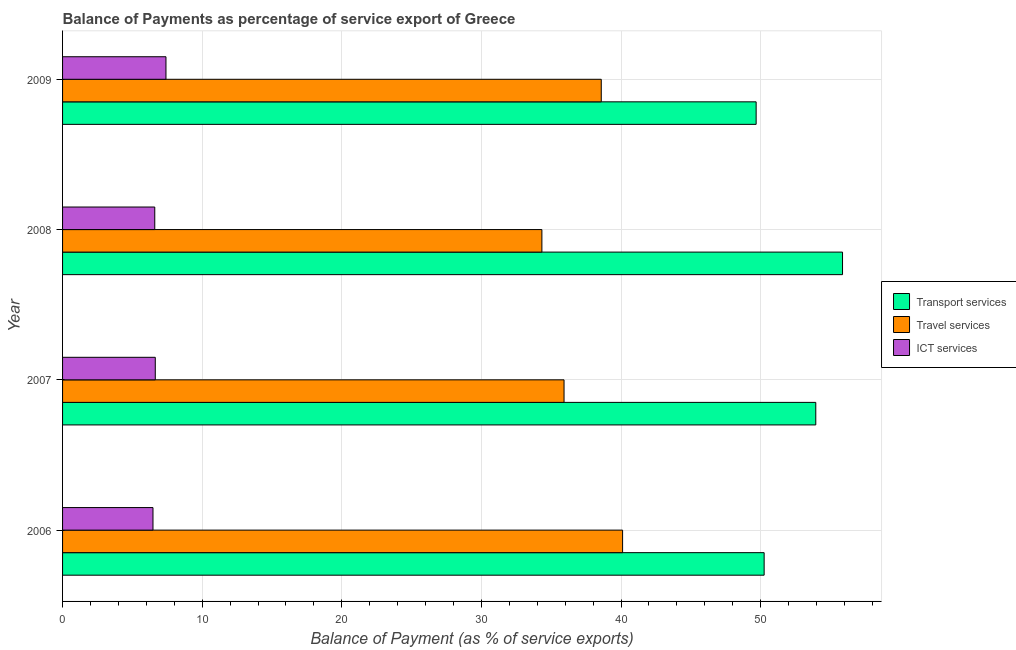How many different coloured bars are there?
Give a very brief answer. 3. How many groups of bars are there?
Your answer should be compact. 4. Are the number of bars on each tick of the Y-axis equal?
Provide a short and direct response. Yes. How many bars are there on the 3rd tick from the top?
Keep it short and to the point. 3. How many bars are there on the 4th tick from the bottom?
Keep it short and to the point. 3. In how many cases, is the number of bars for a given year not equal to the number of legend labels?
Keep it short and to the point. 0. What is the balance of payment of ict services in 2007?
Make the answer very short. 6.64. Across all years, what is the maximum balance of payment of ict services?
Keep it short and to the point. 7.41. Across all years, what is the minimum balance of payment of transport services?
Give a very brief answer. 49.68. In which year was the balance of payment of ict services minimum?
Give a very brief answer. 2006. What is the total balance of payment of travel services in the graph?
Keep it short and to the point. 148.96. What is the difference between the balance of payment of transport services in 2008 and that in 2009?
Provide a short and direct response. 6.19. What is the difference between the balance of payment of ict services in 2006 and the balance of payment of transport services in 2009?
Ensure brevity in your answer.  -43.2. What is the average balance of payment of transport services per year?
Provide a succinct answer. 52.44. In the year 2006, what is the difference between the balance of payment of transport services and balance of payment of travel services?
Your response must be concise. 10.14. What is the ratio of the balance of payment of travel services in 2008 to that in 2009?
Your response must be concise. 0.89. Is the balance of payment of travel services in 2007 less than that in 2009?
Your answer should be compact. Yes. What is the difference between the highest and the second highest balance of payment of transport services?
Provide a succinct answer. 1.92. What is the difference between the highest and the lowest balance of payment of transport services?
Offer a terse response. 6.19. In how many years, is the balance of payment of travel services greater than the average balance of payment of travel services taken over all years?
Your answer should be compact. 2. What does the 1st bar from the top in 2006 represents?
Provide a short and direct response. ICT services. What does the 1st bar from the bottom in 2008 represents?
Ensure brevity in your answer.  Transport services. What is the difference between two consecutive major ticks on the X-axis?
Make the answer very short. 10. Does the graph contain grids?
Provide a short and direct response. Yes. How many legend labels are there?
Provide a succinct answer. 3. What is the title of the graph?
Ensure brevity in your answer.  Balance of Payments as percentage of service export of Greece. What is the label or title of the X-axis?
Provide a short and direct response. Balance of Payment (as % of service exports). What is the label or title of the Y-axis?
Provide a succinct answer. Year. What is the Balance of Payment (as % of service exports) in Transport services in 2006?
Make the answer very short. 50.25. What is the Balance of Payment (as % of service exports) in Travel services in 2006?
Your response must be concise. 40.11. What is the Balance of Payment (as % of service exports) of ICT services in 2006?
Offer a terse response. 6.48. What is the Balance of Payment (as % of service exports) in Transport services in 2007?
Your answer should be compact. 53.95. What is the Balance of Payment (as % of service exports) of Travel services in 2007?
Your answer should be compact. 35.92. What is the Balance of Payment (as % of service exports) of ICT services in 2007?
Make the answer very short. 6.64. What is the Balance of Payment (as % of service exports) in Transport services in 2008?
Offer a terse response. 55.87. What is the Balance of Payment (as % of service exports) of Travel services in 2008?
Provide a succinct answer. 34.33. What is the Balance of Payment (as % of service exports) in ICT services in 2008?
Keep it short and to the point. 6.6. What is the Balance of Payment (as % of service exports) in Transport services in 2009?
Offer a very short reply. 49.68. What is the Balance of Payment (as % of service exports) in Travel services in 2009?
Your response must be concise. 38.59. What is the Balance of Payment (as % of service exports) of ICT services in 2009?
Give a very brief answer. 7.41. Across all years, what is the maximum Balance of Payment (as % of service exports) of Transport services?
Offer a very short reply. 55.87. Across all years, what is the maximum Balance of Payment (as % of service exports) of Travel services?
Offer a very short reply. 40.11. Across all years, what is the maximum Balance of Payment (as % of service exports) of ICT services?
Your response must be concise. 7.41. Across all years, what is the minimum Balance of Payment (as % of service exports) in Transport services?
Your response must be concise. 49.68. Across all years, what is the minimum Balance of Payment (as % of service exports) in Travel services?
Ensure brevity in your answer.  34.33. Across all years, what is the minimum Balance of Payment (as % of service exports) of ICT services?
Provide a succinct answer. 6.48. What is the total Balance of Payment (as % of service exports) in Transport services in the graph?
Ensure brevity in your answer.  209.75. What is the total Balance of Payment (as % of service exports) in Travel services in the graph?
Give a very brief answer. 148.96. What is the total Balance of Payment (as % of service exports) of ICT services in the graph?
Offer a very short reply. 27.13. What is the difference between the Balance of Payment (as % of service exports) of Transport services in 2006 and that in 2007?
Your answer should be very brief. -3.7. What is the difference between the Balance of Payment (as % of service exports) of Travel services in 2006 and that in 2007?
Your response must be concise. 4.19. What is the difference between the Balance of Payment (as % of service exports) in ICT services in 2006 and that in 2007?
Your response must be concise. -0.16. What is the difference between the Balance of Payment (as % of service exports) of Transport services in 2006 and that in 2008?
Your answer should be compact. -5.61. What is the difference between the Balance of Payment (as % of service exports) of Travel services in 2006 and that in 2008?
Make the answer very short. 5.78. What is the difference between the Balance of Payment (as % of service exports) of ICT services in 2006 and that in 2008?
Make the answer very short. -0.13. What is the difference between the Balance of Payment (as % of service exports) in Transport services in 2006 and that in 2009?
Offer a terse response. 0.57. What is the difference between the Balance of Payment (as % of service exports) of Travel services in 2006 and that in 2009?
Offer a very short reply. 1.53. What is the difference between the Balance of Payment (as % of service exports) of ICT services in 2006 and that in 2009?
Your answer should be compact. -0.93. What is the difference between the Balance of Payment (as % of service exports) in Transport services in 2007 and that in 2008?
Offer a terse response. -1.92. What is the difference between the Balance of Payment (as % of service exports) of Travel services in 2007 and that in 2008?
Your answer should be compact. 1.59. What is the difference between the Balance of Payment (as % of service exports) in ICT services in 2007 and that in 2008?
Ensure brevity in your answer.  0.04. What is the difference between the Balance of Payment (as % of service exports) of Transport services in 2007 and that in 2009?
Provide a succinct answer. 4.27. What is the difference between the Balance of Payment (as % of service exports) in Travel services in 2007 and that in 2009?
Offer a very short reply. -2.67. What is the difference between the Balance of Payment (as % of service exports) in ICT services in 2007 and that in 2009?
Ensure brevity in your answer.  -0.77. What is the difference between the Balance of Payment (as % of service exports) of Transport services in 2008 and that in 2009?
Give a very brief answer. 6.19. What is the difference between the Balance of Payment (as % of service exports) of Travel services in 2008 and that in 2009?
Keep it short and to the point. -4.25. What is the difference between the Balance of Payment (as % of service exports) in ICT services in 2008 and that in 2009?
Make the answer very short. -0.8. What is the difference between the Balance of Payment (as % of service exports) of Transport services in 2006 and the Balance of Payment (as % of service exports) of Travel services in 2007?
Offer a very short reply. 14.33. What is the difference between the Balance of Payment (as % of service exports) of Transport services in 2006 and the Balance of Payment (as % of service exports) of ICT services in 2007?
Provide a succinct answer. 43.61. What is the difference between the Balance of Payment (as % of service exports) in Travel services in 2006 and the Balance of Payment (as % of service exports) in ICT services in 2007?
Your answer should be very brief. 33.47. What is the difference between the Balance of Payment (as % of service exports) of Transport services in 2006 and the Balance of Payment (as % of service exports) of Travel services in 2008?
Offer a terse response. 15.92. What is the difference between the Balance of Payment (as % of service exports) of Transport services in 2006 and the Balance of Payment (as % of service exports) of ICT services in 2008?
Your answer should be very brief. 43.65. What is the difference between the Balance of Payment (as % of service exports) in Travel services in 2006 and the Balance of Payment (as % of service exports) in ICT services in 2008?
Your response must be concise. 33.51. What is the difference between the Balance of Payment (as % of service exports) in Transport services in 2006 and the Balance of Payment (as % of service exports) in Travel services in 2009?
Make the answer very short. 11.67. What is the difference between the Balance of Payment (as % of service exports) of Transport services in 2006 and the Balance of Payment (as % of service exports) of ICT services in 2009?
Your answer should be compact. 42.85. What is the difference between the Balance of Payment (as % of service exports) of Travel services in 2006 and the Balance of Payment (as % of service exports) of ICT services in 2009?
Offer a very short reply. 32.71. What is the difference between the Balance of Payment (as % of service exports) in Transport services in 2007 and the Balance of Payment (as % of service exports) in Travel services in 2008?
Offer a terse response. 19.62. What is the difference between the Balance of Payment (as % of service exports) in Transport services in 2007 and the Balance of Payment (as % of service exports) in ICT services in 2008?
Your answer should be compact. 47.35. What is the difference between the Balance of Payment (as % of service exports) in Travel services in 2007 and the Balance of Payment (as % of service exports) in ICT services in 2008?
Offer a very short reply. 29.32. What is the difference between the Balance of Payment (as % of service exports) in Transport services in 2007 and the Balance of Payment (as % of service exports) in Travel services in 2009?
Your answer should be very brief. 15.37. What is the difference between the Balance of Payment (as % of service exports) of Transport services in 2007 and the Balance of Payment (as % of service exports) of ICT services in 2009?
Your response must be concise. 46.55. What is the difference between the Balance of Payment (as % of service exports) in Travel services in 2007 and the Balance of Payment (as % of service exports) in ICT services in 2009?
Offer a terse response. 28.51. What is the difference between the Balance of Payment (as % of service exports) of Transport services in 2008 and the Balance of Payment (as % of service exports) of Travel services in 2009?
Your answer should be compact. 17.28. What is the difference between the Balance of Payment (as % of service exports) in Transport services in 2008 and the Balance of Payment (as % of service exports) in ICT services in 2009?
Your answer should be very brief. 48.46. What is the difference between the Balance of Payment (as % of service exports) of Travel services in 2008 and the Balance of Payment (as % of service exports) of ICT services in 2009?
Offer a very short reply. 26.93. What is the average Balance of Payment (as % of service exports) in Transport services per year?
Make the answer very short. 52.44. What is the average Balance of Payment (as % of service exports) in Travel services per year?
Keep it short and to the point. 37.24. What is the average Balance of Payment (as % of service exports) of ICT services per year?
Offer a terse response. 6.78. In the year 2006, what is the difference between the Balance of Payment (as % of service exports) of Transport services and Balance of Payment (as % of service exports) of Travel services?
Make the answer very short. 10.14. In the year 2006, what is the difference between the Balance of Payment (as % of service exports) of Transport services and Balance of Payment (as % of service exports) of ICT services?
Give a very brief answer. 43.78. In the year 2006, what is the difference between the Balance of Payment (as % of service exports) of Travel services and Balance of Payment (as % of service exports) of ICT services?
Your response must be concise. 33.64. In the year 2007, what is the difference between the Balance of Payment (as % of service exports) in Transport services and Balance of Payment (as % of service exports) in Travel services?
Ensure brevity in your answer.  18.03. In the year 2007, what is the difference between the Balance of Payment (as % of service exports) of Transport services and Balance of Payment (as % of service exports) of ICT services?
Your answer should be compact. 47.31. In the year 2007, what is the difference between the Balance of Payment (as % of service exports) in Travel services and Balance of Payment (as % of service exports) in ICT services?
Give a very brief answer. 29.28. In the year 2008, what is the difference between the Balance of Payment (as % of service exports) in Transport services and Balance of Payment (as % of service exports) in Travel services?
Keep it short and to the point. 21.53. In the year 2008, what is the difference between the Balance of Payment (as % of service exports) in Transport services and Balance of Payment (as % of service exports) in ICT services?
Offer a terse response. 49.26. In the year 2008, what is the difference between the Balance of Payment (as % of service exports) in Travel services and Balance of Payment (as % of service exports) in ICT services?
Offer a very short reply. 27.73. In the year 2009, what is the difference between the Balance of Payment (as % of service exports) of Transport services and Balance of Payment (as % of service exports) of Travel services?
Give a very brief answer. 11.09. In the year 2009, what is the difference between the Balance of Payment (as % of service exports) in Transport services and Balance of Payment (as % of service exports) in ICT services?
Your answer should be very brief. 42.27. In the year 2009, what is the difference between the Balance of Payment (as % of service exports) of Travel services and Balance of Payment (as % of service exports) of ICT services?
Keep it short and to the point. 31.18. What is the ratio of the Balance of Payment (as % of service exports) in Transport services in 2006 to that in 2007?
Ensure brevity in your answer.  0.93. What is the ratio of the Balance of Payment (as % of service exports) in Travel services in 2006 to that in 2007?
Keep it short and to the point. 1.12. What is the ratio of the Balance of Payment (as % of service exports) in ICT services in 2006 to that in 2007?
Your answer should be compact. 0.98. What is the ratio of the Balance of Payment (as % of service exports) in Transport services in 2006 to that in 2008?
Provide a succinct answer. 0.9. What is the ratio of the Balance of Payment (as % of service exports) in Travel services in 2006 to that in 2008?
Your answer should be compact. 1.17. What is the ratio of the Balance of Payment (as % of service exports) in ICT services in 2006 to that in 2008?
Make the answer very short. 0.98. What is the ratio of the Balance of Payment (as % of service exports) in Transport services in 2006 to that in 2009?
Your answer should be compact. 1.01. What is the ratio of the Balance of Payment (as % of service exports) of Travel services in 2006 to that in 2009?
Ensure brevity in your answer.  1.04. What is the ratio of the Balance of Payment (as % of service exports) in ICT services in 2006 to that in 2009?
Offer a very short reply. 0.87. What is the ratio of the Balance of Payment (as % of service exports) of Transport services in 2007 to that in 2008?
Keep it short and to the point. 0.97. What is the ratio of the Balance of Payment (as % of service exports) of Travel services in 2007 to that in 2008?
Provide a short and direct response. 1.05. What is the ratio of the Balance of Payment (as % of service exports) in ICT services in 2007 to that in 2008?
Offer a very short reply. 1.01. What is the ratio of the Balance of Payment (as % of service exports) in Transport services in 2007 to that in 2009?
Your answer should be compact. 1.09. What is the ratio of the Balance of Payment (as % of service exports) in Travel services in 2007 to that in 2009?
Your answer should be very brief. 0.93. What is the ratio of the Balance of Payment (as % of service exports) of ICT services in 2007 to that in 2009?
Make the answer very short. 0.9. What is the ratio of the Balance of Payment (as % of service exports) of Transport services in 2008 to that in 2009?
Provide a succinct answer. 1.12. What is the ratio of the Balance of Payment (as % of service exports) in Travel services in 2008 to that in 2009?
Your answer should be very brief. 0.89. What is the ratio of the Balance of Payment (as % of service exports) of ICT services in 2008 to that in 2009?
Your response must be concise. 0.89. What is the difference between the highest and the second highest Balance of Payment (as % of service exports) in Transport services?
Your response must be concise. 1.92. What is the difference between the highest and the second highest Balance of Payment (as % of service exports) in Travel services?
Provide a succinct answer. 1.53. What is the difference between the highest and the second highest Balance of Payment (as % of service exports) in ICT services?
Make the answer very short. 0.77. What is the difference between the highest and the lowest Balance of Payment (as % of service exports) in Transport services?
Keep it short and to the point. 6.19. What is the difference between the highest and the lowest Balance of Payment (as % of service exports) of Travel services?
Ensure brevity in your answer.  5.78. 